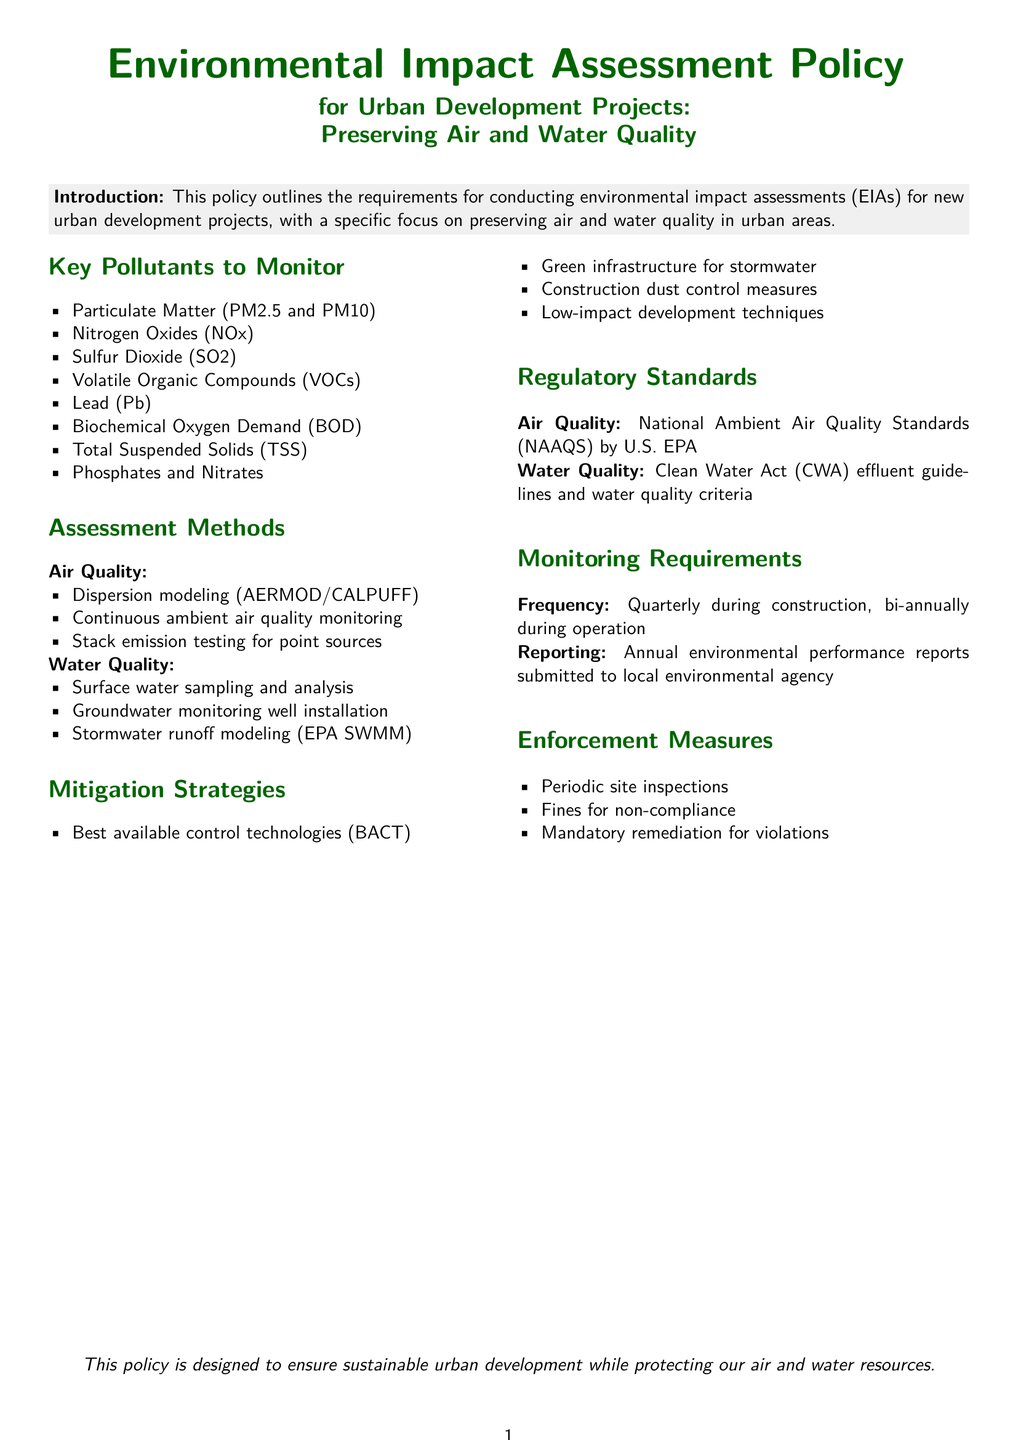What is the title of the policy document? The title is prominently displayed at the top of the document and outlines its main focus.
Answer: Environmental Impact Assessment Policy What are the key pollutants to monitor for air quality? The section lists specific pollutants identified as important for air quality in urban development projects.
Answer: Particulate Matter (PM2.5 and PM10) What assessment method is used for water quality? The document specifies different methods of assessing water quality, including sampling techniques.
Answer: Surface water sampling and analysis What organization sets the air quality regulatory standards? The document names the organization responsible for setting the air quality regulations.
Answer: U.S. EPA What is the frequency of monitoring during construction? The policy outlines the required frequency of monitoring activities during the construction phase.
Answer: Quarterly What is the consequence for non-compliance mentioned in the document? The document lists a specific enforcement measure that serves as a consequence for failing to comply with the policy.
Answer: Fines for non-compliance What is one mitigation strategy mentioned for stormwater? The policy outlines specific strategies to mitigate impacts on stormwater resulting from urban development.
Answer: Green infrastructure for stormwater How often are environmental performance reports submitted? The policy details the reporting requirements for monitoring compliance with environmental standards.
Answer: Annually 